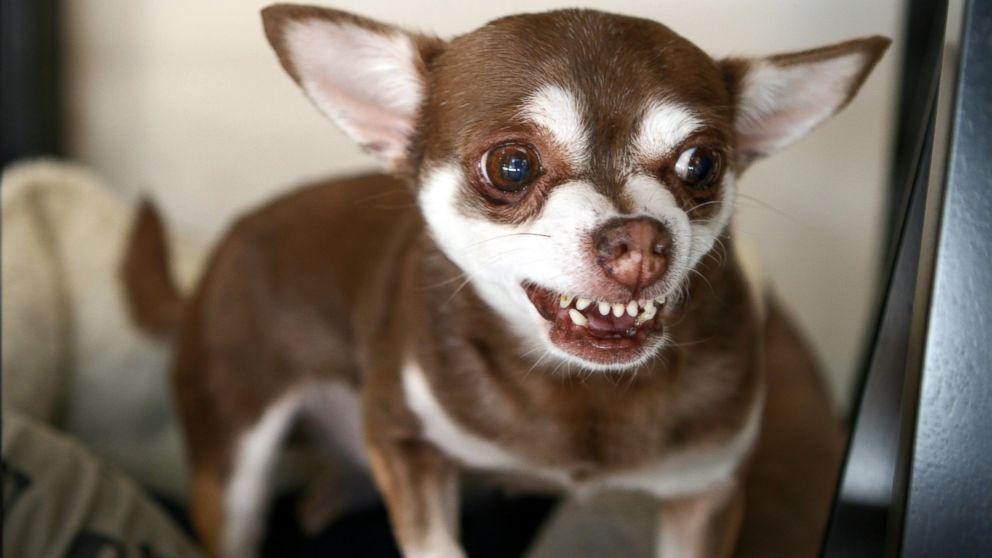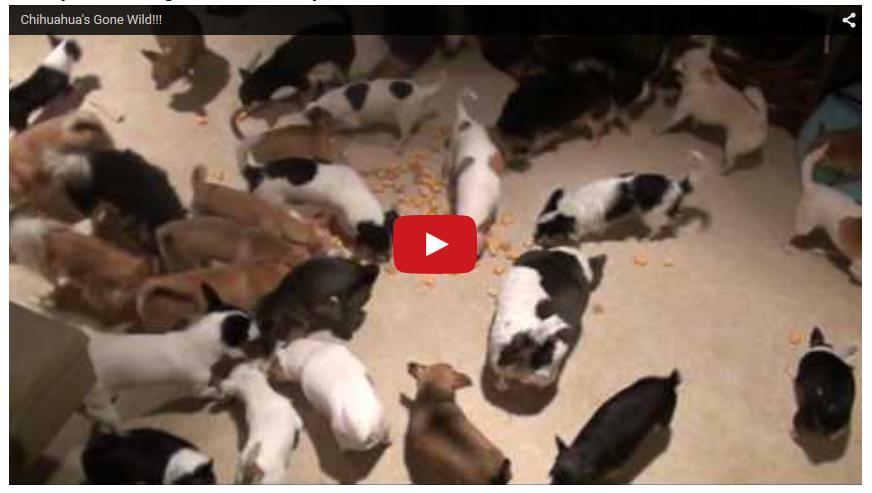The first image is the image on the left, the second image is the image on the right. Evaluate the accuracy of this statement regarding the images: "There is exactly one real dog in the image on the left.". Is it true? Answer yes or no. Yes. 